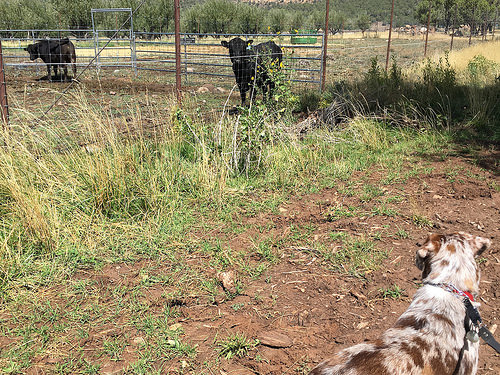<image>
Can you confirm if the compound is to the left of the dog? Yes. From this viewpoint, the compound is positioned to the left side relative to the dog. 